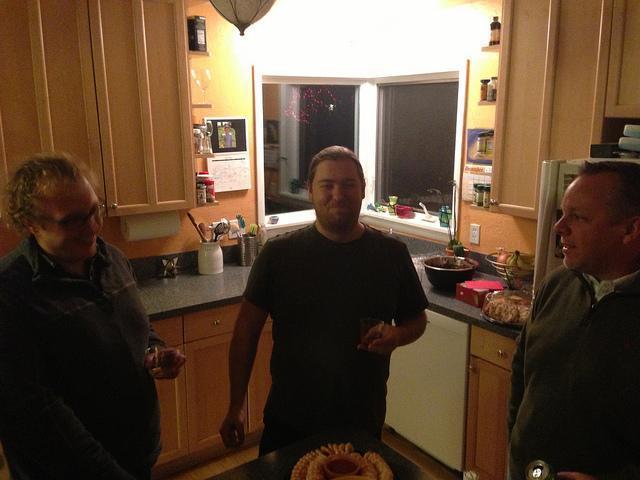How many men are in this picture?
Give a very brief answer. 3. How many people can you see?
Give a very brief answer. 3. 